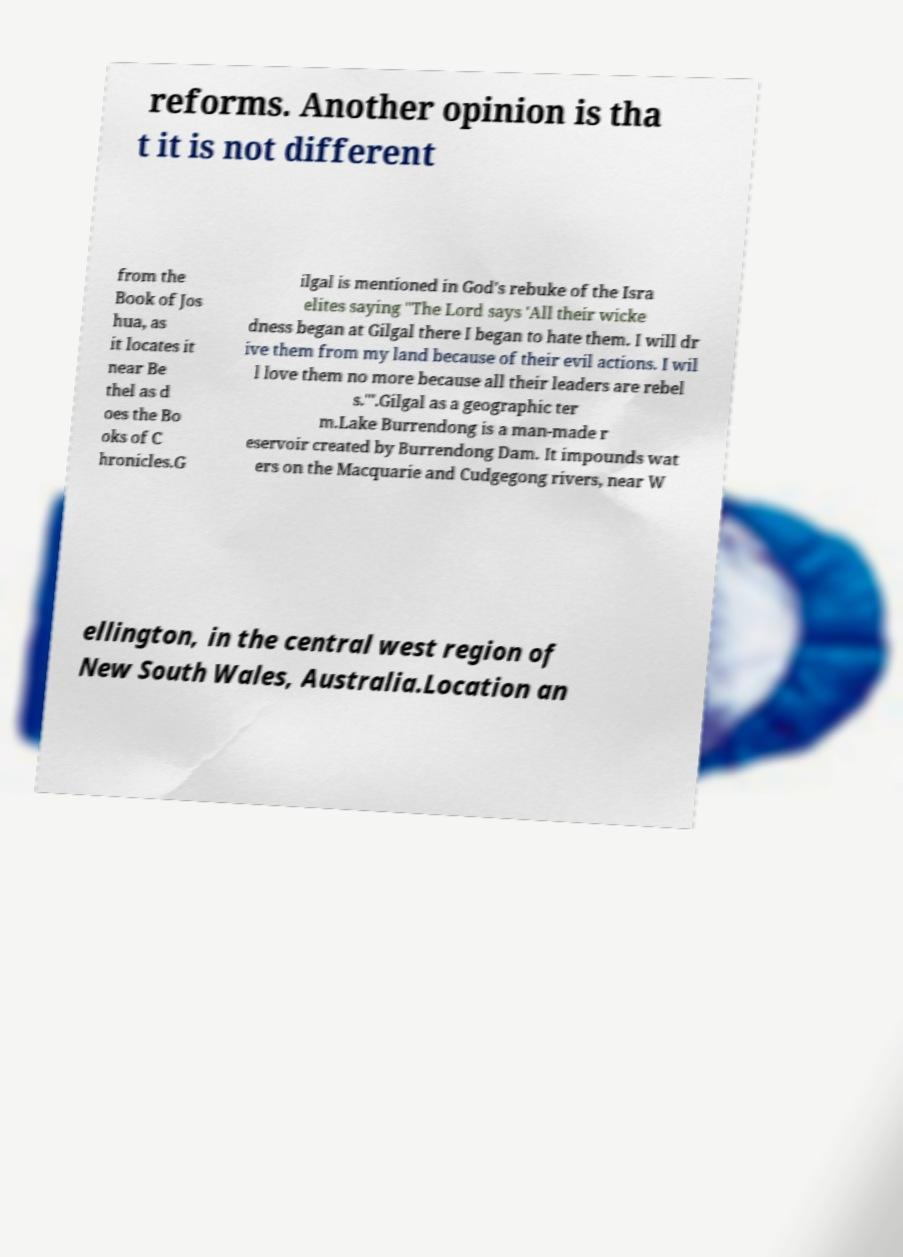Could you extract and type out the text from this image? reforms. Another opinion is tha t it is not different from the Book of Jos hua, as it locates it near Be thel as d oes the Bo oks of C hronicles.G ilgal is mentioned in God's rebuke of the Isra elites saying "The Lord says 'All their wicke dness began at Gilgal there I began to hate them. I will dr ive them from my land because of their evil actions. I wil l love them no more because all their leaders are rebel s.'".Gilgal as a geographic ter m.Lake Burrendong is a man-made r eservoir created by Burrendong Dam. It impounds wat ers on the Macquarie and Cudgegong rivers, near W ellington, in the central west region of New South Wales, Australia.Location an 